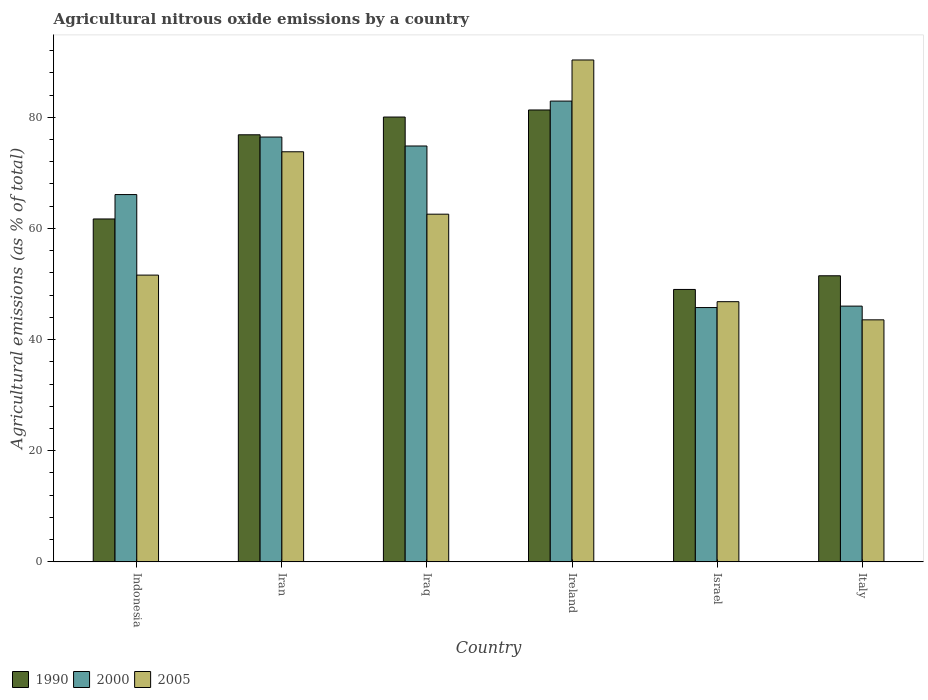How many different coloured bars are there?
Ensure brevity in your answer.  3. Are the number of bars per tick equal to the number of legend labels?
Make the answer very short. Yes. Are the number of bars on each tick of the X-axis equal?
Your answer should be very brief. Yes. How many bars are there on the 3rd tick from the left?
Your answer should be compact. 3. How many bars are there on the 2nd tick from the right?
Your answer should be compact. 3. What is the label of the 3rd group of bars from the left?
Offer a terse response. Iraq. What is the amount of agricultural nitrous oxide emitted in 2000 in Ireland?
Make the answer very short. 82.91. Across all countries, what is the maximum amount of agricultural nitrous oxide emitted in 2000?
Your answer should be very brief. 82.91. Across all countries, what is the minimum amount of agricultural nitrous oxide emitted in 2005?
Give a very brief answer. 43.55. In which country was the amount of agricultural nitrous oxide emitted in 2000 maximum?
Offer a terse response. Ireland. What is the total amount of agricultural nitrous oxide emitted in 2000 in the graph?
Keep it short and to the point. 392.04. What is the difference between the amount of agricultural nitrous oxide emitted in 1990 in Iraq and that in Israel?
Offer a terse response. 31.02. What is the difference between the amount of agricultural nitrous oxide emitted in 1990 in Iraq and the amount of agricultural nitrous oxide emitted in 2000 in Ireland?
Make the answer very short. -2.87. What is the average amount of agricultural nitrous oxide emitted in 1990 per country?
Make the answer very short. 66.73. What is the difference between the amount of agricultural nitrous oxide emitted of/in 1990 and amount of agricultural nitrous oxide emitted of/in 2005 in Iraq?
Provide a succinct answer. 17.48. What is the ratio of the amount of agricultural nitrous oxide emitted in 2000 in Iran to that in Ireland?
Ensure brevity in your answer.  0.92. Is the amount of agricultural nitrous oxide emitted in 2005 in Israel less than that in Italy?
Make the answer very short. No. What is the difference between the highest and the second highest amount of agricultural nitrous oxide emitted in 2005?
Your answer should be very brief. -16.52. What is the difference between the highest and the lowest amount of agricultural nitrous oxide emitted in 1990?
Your response must be concise. 32.29. In how many countries, is the amount of agricultural nitrous oxide emitted in 2005 greater than the average amount of agricultural nitrous oxide emitted in 2005 taken over all countries?
Make the answer very short. 3. Is the sum of the amount of agricultural nitrous oxide emitted in 2005 in Iran and Italy greater than the maximum amount of agricultural nitrous oxide emitted in 1990 across all countries?
Provide a short and direct response. Yes. What does the 3rd bar from the left in Israel represents?
Ensure brevity in your answer.  2005. What does the 2nd bar from the right in Iraq represents?
Make the answer very short. 2000. Is it the case that in every country, the sum of the amount of agricultural nitrous oxide emitted in 2000 and amount of agricultural nitrous oxide emitted in 1990 is greater than the amount of agricultural nitrous oxide emitted in 2005?
Make the answer very short. Yes. What is the difference between two consecutive major ticks on the Y-axis?
Offer a very short reply. 20. Does the graph contain any zero values?
Your answer should be very brief. No. Where does the legend appear in the graph?
Your response must be concise. Bottom left. What is the title of the graph?
Make the answer very short. Agricultural nitrous oxide emissions by a country. What is the label or title of the Y-axis?
Offer a terse response. Agricultural emissions (as % of total). What is the Agricultural emissions (as % of total) of 1990 in Indonesia?
Offer a very short reply. 61.7. What is the Agricultural emissions (as % of total) of 2000 in Indonesia?
Keep it short and to the point. 66.09. What is the Agricultural emissions (as % of total) in 2005 in Indonesia?
Offer a terse response. 51.6. What is the Agricultural emissions (as % of total) in 1990 in Iran?
Provide a succinct answer. 76.84. What is the Agricultural emissions (as % of total) in 2000 in Iran?
Offer a terse response. 76.44. What is the Agricultural emissions (as % of total) of 2005 in Iran?
Provide a short and direct response. 73.79. What is the Agricultural emissions (as % of total) in 1990 in Iraq?
Your response must be concise. 80.04. What is the Agricultural emissions (as % of total) of 2000 in Iraq?
Your response must be concise. 74.83. What is the Agricultural emissions (as % of total) in 2005 in Iraq?
Your answer should be very brief. 62.56. What is the Agricultural emissions (as % of total) in 1990 in Ireland?
Offer a terse response. 81.31. What is the Agricultural emissions (as % of total) in 2000 in Ireland?
Keep it short and to the point. 82.91. What is the Agricultural emissions (as % of total) of 2005 in Ireland?
Keep it short and to the point. 90.31. What is the Agricultural emissions (as % of total) in 1990 in Israel?
Offer a terse response. 49.02. What is the Agricultural emissions (as % of total) of 2000 in Israel?
Provide a succinct answer. 45.76. What is the Agricultural emissions (as % of total) of 2005 in Israel?
Give a very brief answer. 46.82. What is the Agricultural emissions (as % of total) in 1990 in Italy?
Provide a succinct answer. 51.48. What is the Agricultural emissions (as % of total) in 2000 in Italy?
Ensure brevity in your answer.  46.02. What is the Agricultural emissions (as % of total) in 2005 in Italy?
Your answer should be very brief. 43.55. Across all countries, what is the maximum Agricultural emissions (as % of total) in 1990?
Give a very brief answer. 81.31. Across all countries, what is the maximum Agricultural emissions (as % of total) of 2000?
Your answer should be very brief. 82.91. Across all countries, what is the maximum Agricultural emissions (as % of total) in 2005?
Provide a succinct answer. 90.31. Across all countries, what is the minimum Agricultural emissions (as % of total) in 1990?
Give a very brief answer. 49.02. Across all countries, what is the minimum Agricultural emissions (as % of total) in 2000?
Your response must be concise. 45.76. Across all countries, what is the minimum Agricultural emissions (as % of total) of 2005?
Offer a very short reply. 43.55. What is the total Agricultural emissions (as % of total) in 1990 in the graph?
Offer a terse response. 400.39. What is the total Agricultural emissions (as % of total) of 2000 in the graph?
Your answer should be compact. 392.04. What is the total Agricultural emissions (as % of total) in 2005 in the graph?
Ensure brevity in your answer.  368.62. What is the difference between the Agricultural emissions (as % of total) of 1990 in Indonesia and that in Iran?
Provide a succinct answer. -15.14. What is the difference between the Agricultural emissions (as % of total) in 2000 in Indonesia and that in Iran?
Offer a terse response. -10.35. What is the difference between the Agricultural emissions (as % of total) of 2005 in Indonesia and that in Iran?
Give a very brief answer. -22.19. What is the difference between the Agricultural emissions (as % of total) in 1990 in Indonesia and that in Iraq?
Offer a terse response. -18.34. What is the difference between the Agricultural emissions (as % of total) of 2000 in Indonesia and that in Iraq?
Make the answer very short. -8.74. What is the difference between the Agricultural emissions (as % of total) in 2005 in Indonesia and that in Iraq?
Provide a succinct answer. -10.96. What is the difference between the Agricultural emissions (as % of total) of 1990 in Indonesia and that in Ireland?
Offer a terse response. -19.61. What is the difference between the Agricultural emissions (as % of total) in 2000 in Indonesia and that in Ireland?
Provide a short and direct response. -16.82. What is the difference between the Agricultural emissions (as % of total) in 2005 in Indonesia and that in Ireland?
Your answer should be very brief. -38.71. What is the difference between the Agricultural emissions (as % of total) in 1990 in Indonesia and that in Israel?
Provide a short and direct response. 12.68. What is the difference between the Agricultural emissions (as % of total) of 2000 in Indonesia and that in Israel?
Ensure brevity in your answer.  20.33. What is the difference between the Agricultural emissions (as % of total) of 2005 in Indonesia and that in Israel?
Offer a very short reply. 4.78. What is the difference between the Agricultural emissions (as % of total) in 1990 in Indonesia and that in Italy?
Your answer should be very brief. 10.22. What is the difference between the Agricultural emissions (as % of total) in 2000 in Indonesia and that in Italy?
Ensure brevity in your answer.  20.07. What is the difference between the Agricultural emissions (as % of total) of 2005 in Indonesia and that in Italy?
Offer a terse response. 8.05. What is the difference between the Agricultural emissions (as % of total) of 1990 in Iran and that in Iraq?
Provide a succinct answer. -3.19. What is the difference between the Agricultural emissions (as % of total) in 2000 in Iran and that in Iraq?
Provide a short and direct response. 1.61. What is the difference between the Agricultural emissions (as % of total) of 2005 in Iran and that in Iraq?
Your response must be concise. 11.23. What is the difference between the Agricultural emissions (as % of total) in 1990 in Iran and that in Ireland?
Ensure brevity in your answer.  -4.47. What is the difference between the Agricultural emissions (as % of total) of 2000 in Iran and that in Ireland?
Make the answer very short. -6.47. What is the difference between the Agricultural emissions (as % of total) of 2005 in Iran and that in Ireland?
Your answer should be very brief. -16.52. What is the difference between the Agricultural emissions (as % of total) in 1990 in Iran and that in Israel?
Give a very brief answer. 27.83. What is the difference between the Agricultural emissions (as % of total) in 2000 in Iran and that in Israel?
Your answer should be compact. 30.68. What is the difference between the Agricultural emissions (as % of total) in 2005 in Iran and that in Israel?
Give a very brief answer. 26.97. What is the difference between the Agricultural emissions (as % of total) of 1990 in Iran and that in Italy?
Make the answer very short. 25.37. What is the difference between the Agricultural emissions (as % of total) in 2000 in Iran and that in Italy?
Ensure brevity in your answer.  30.42. What is the difference between the Agricultural emissions (as % of total) of 2005 in Iran and that in Italy?
Provide a succinct answer. 30.24. What is the difference between the Agricultural emissions (as % of total) in 1990 in Iraq and that in Ireland?
Ensure brevity in your answer.  -1.27. What is the difference between the Agricultural emissions (as % of total) of 2000 in Iraq and that in Ireland?
Give a very brief answer. -8.08. What is the difference between the Agricultural emissions (as % of total) of 2005 in Iraq and that in Ireland?
Give a very brief answer. -27.75. What is the difference between the Agricultural emissions (as % of total) of 1990 in Iraq and that in Israel?
Your answer should be compact. 31.02. What is the difference between the Agricultural emissions (as % of total) in 2000 in Iraq and that in Israel?
Ensure brevity in your answer.  29.07. What is the difference between the Agricultural emissions (as % of total) in 2005 in Iraq and that in Israel?
Give a very brief answer. 15.74. What is the difference between the Agricultural emissions (as % of total) in 1990 in Iraq and that in Italy?
Offer a terse response. 28.56. What is the difference between the Agricultural emissions (as % of total) in 2000 in Iraq and that in Italy?
Make the answer very short. 28.81. What is the difference between the Agricultural emissions (as % of total) of 2005 in Iraq and that in Italy?
Your response must be concise. 19.01. What is the difference between the Agricultural emissions (as % of total) in 1990 in Ireland and that in Israel?
Give a very brief answer. 32.29. What is the difference between the Agricultural emissions (as % of total) of 2000 in Ireland and that in Israel?
Provide a short and direct response. 37.15. What is the difference between the Agricultural emissions (as % of total) of 2005 in Ireland and that in Israel?
Give a very brief answer. 43.49. What is the difference between the Agricultural emissions (as % of total) in 1990 in Ireland and that in Italy?
Ensure brevity in your answer.  29.83. What is the difference between the Agricultural emissions (as % of total) in 2000 in Ireland and that in Italy?
Provide a short and direct response. 36.89. What is the difference between the Agricultural emissions (as % of total) of 2005 in Ireland and that in Italy?
Your answer should be compact. 46.76. What is the difference between the Agricultural emissions (as % of total) in 1990 in Israel and that in Italy?
Ensure brevity in your answer.  -2.46. What is the difference between the Agricultural emissions (as % of total) of 2000 in Israel and that in Italy?
Offer a very short reply. -0.26. What is the difference between the Agricultural emissions (as % of total) of 2005 in Israel and that in Italy?
Provide a succinct answer. 3.27. What is the difference between the Agricultural emissions (as % of total) of 1990 in Indonesia and the Agricultural emissions (as % of total) of 2000 in Iran?
Your response must be concise. -14.74. What is the difference between the Agricultural emissions (as % of total) of 1990 in Indonesia and the Agricultural emissions (as % of total) of 2005 in Iran?
Offer a very short reply. -12.09. What is the difference between the Agricultural emissions (as % of total) of 2000 in Indonesia and the Agricultural emissions (as % of total) of 2005 in Iran?
Your response must be concise. -7.7. What is the difference between the Agricultural emissions (as % of total) of 1990 in Indonesia and the Agricultural emissions (as % of total) of 2000 in Iraq?
Give a very brief answer. -13.13. What is the difference between the Agricultural emissions (as % of total) of 1990 in Indonesia and the Agricultural emissions (as % of total) of 2005 in Iraq?
Keep it short and to the point. -0.86. What is the difference between the Agricultural emissions (as % of total) in 2000 in Indonesia and the Agricultural emissions (as % of total) in 2005 in Iraq?
Your answer should be very brief. 3.53. What is the difference between the Agricultural emissions (as % of total) of 1990 in Indonesia and the Agricultural emissions (as % of total) of 2000 in Ireland?
Your answer should be compact. -21.21. What is the difference between the Agricultural emissions (as % of total) of 1990 in Indonesia and the Agricultural emissions (as % of total) of 2005 in Ireland?
Ensure brevity in your answer.  -28.61. What is the difference between the Agricultural emissions (as % of total) in 2000 in Indonesia and the Agricultural emissions (as % of total) in 2005 in Ireland?
Your answer should be very brief. -24.22. What is the difference between the Agricultural emissions (as % of total) of 1990 in Indonesia and the Agricultural emissions (as % of total) of 2000 in Israel?
Give a very brief answer. 15.94. What is the difference between the Agricultural emissions (as % of total) of 1990 in Indonesia and the Agricultural emissions (as % of total) of 2005 in Israel?
Give a very brief answer. 14.88. What is the difference between the Agricultural emissions (as % of total) of 2000 in Indonesia and the Agricultural emissions (as % of total) of 2005 in Israel?
Provide a succinct answer. 19.27. What is the difference between the Agricultural emissions (as % of total) in 1990 in Indonesia and the Agricultural emissions (as % of total) in 2000 in Italy?
Your answer should be very brief. 15.68. What is the difference between the Agricultural emissions (as % of total) in 1990 in Indonesia and the Agricultural emissions (as % of total) in 2005 in Italy?
Provide a short and direct response. 18.15. What is the difference between the Agricultural emissions (as % of total) in 2000 in Indonesia and the Agricultural emissions (as % of total) in 2005 in Italy?
Your answer should be compact. 22.54. What is the difference between the Agricultural emissions (as % of total) of 1990 in Iran and the Agricultural emissions (as % of total) of 2000 in Iraq?
Ensure brevity in your answer.  2.02. What is the difference between the Agricultural emissions (as % of total) in 1990 in Iran and the Agricultural emissions (as % of total) in 2005 in Iraq?
Ensure brevity in your answer.  14.29. What is the difference between the Agricultural emissions (as % of total) of 2000 in Iran and the Agricultural emissions (as % of total) of 2005 in Iraq?
Your answer should be compact. 13.88. What is the difference between the Agricultural emissions (as % of total) in 1990 in Iran and the Agricultural emissions (as % of total) in 2000 in Ireland?
Offer a very short reply. -6.06. What is the difference between the Agricultural emissions (as % of total) in 1990 in Iran and the Agricultural emissions (as % of total) in 2005 in Ireland?
Keep it short and to the point. -13.46. What is the difference between the Agricultural emissions (as % of total) in 2000 in Iran and the Agricultural emissions (as % of total) in 2005 in Ireland?
Make the answer very short. -13.87. What is the difference between the Agricultural emissions (as % of total) of 1990 in Iran and the Agricultural emissions (as % of total) of 2000 in Israel?
Provide a succinct answer. 31.08. What is the difference between the Agricultural emissions (as % of total) of 1990 in Iran and the Agricultural emissions (as % of total) of 2005 in Israel?
Provide a short and direct response. 30.03. What is the difference between the Agricultural emissions (as % of total) in 2000 in Iran and the Agricultural emissions (as % of total) in 2005 in Israel?
Ensure brevity in your answer.  29.62. What is the difference between the Agricultural emissions (as % of total) in 1990 in Iran and the Agricultural emissions (as % of total) in 2000 in Italy?
Make the answer very short. 30.83. What is the difference between the Agricultural emissions (as % of total) of 1990 in Iran and the Agricultural emissions (as % of total) of 2005 in Italy?
Your answer should be compact. 33.3. What is the difference between the Agricultural emissions (as % of total) of 2000 in Iran and the Agricultural emissions (as % of total) of 2005 in Italy?
Your answer should be very brief. 32.89. What is the difference between the Agricultural emissions (as % of total) in 1990 in Iraq and the Agricultural emissions (as % of total) in 2000 in Ireland?
Offer a very short reply. -2.87. What is the difference between the Agricultural emissions (as % of total) in 1990 in Iraq and the Agricultural emissions (as % of total) in 2005 in Ireland?
Your answer should be compact. -10.27. What is the difference between the Agricultural emissions (as % of total) of 2000 in Iraq and the Agricultural emissions (as % of total) of 2005 in Ireland?
Make the answer very short. -15.48. What is the difference between the Agricultural emissions (as % of total) of 1990 in Iraq and the Agricultural emissions (as % of total) of 2000 in Israel?
Offer a very short reply. 34.28. What is the difference between the Agricultural emissions (as % of total) of 1990 in Iraq and the Agricultural emissions (as % of total) of 2005 in Israel?
Your response must be concise. 33.22. What is the difference between the Agricultural emissions (as % of total) of 2000 in Iraq and the Agricultural emissions (as % of total) of 2005 in Israel?
Offer a terse response. 28.01. What is the difference between the Agricultural emissions (as % of total) in 1990 in Iraq and the Agricultural emissions (as % of total) in 2000 in Italy?
Your answer should be very brief. 34.02. What is the difference between the Agricultural emissions (as % of total) in 1990 in Iraq and the Agricultural emissions (as % of total) in 2005 in Italy?
Your answer should be compact. 36.49. What is the difference between the Agricultural emissions (as % of total) of 2000 in Iraq and the Agricultural emissions (as % of total) of 2005 in Italy?
Provide a short and direct response. 31.28. What is the difference between the Agricultural emissions (as % of total) of 1990 in Ireland and the Agricultural emissions (as % of total) of 2000 in Israel?
Provide a succinct answer. 35.55. What is the difference between the Agricultural emissions (as % of total) of 1990 in Ireland and the Agricultural emissions (as % of total) of 2005 in Israel?
Your answer should be compact. 34.49. What is the difference between the Agricultural emissions (as % of total) of 2000 in Ireland and the Agricultural emissions (as % of total) of 2005 in Israel?
Your response must be concise. 36.09. What is the difference between the Agricultural emissions (as % of total) in 1990 in Ireland and the Agricultural emissions (as % of total) in 2000 in Italy?
Make the answer very short. 35.29. What is the difference between the Agricultural emissions (as % of total) of 1990 in Ireland and the Agricultural emissions (as % of total) of 2005 in Italy?
Offer a very short reply. 37.76. What is the difference between the Agricultural emissions (as % of total) in 2000 in Ireland and the Agricultural emissions (as % of total) in 2005 in Italy?
Your response must be concise. 39.36. What is the difference between the Agricultural emissions (as % of total) of 1990 in Israel and the Agricultural emissions (as % of total) of 2000 in Italy?
Provide a short and direct response. 3. What is the difference between the Agricultural emissions (as % of total) of 1990 in Israel and the Agricultural emissions (as % of total) of 2005 in Italy?
Your response must be concise. 5.47. What is the difference between the Agricultural emissions (as % of total) of 2000 in Israel and the Agricultural emissions (as % of total) of 2005 in Italy?
Keep it short and to the point. 2.21. What is the average Agricultural emissions (as % of total) in 1990 per country?
Keep it short and to the point. 66.73. What is the average Agricultural emissions (as % of total) in 2000 per country?
Offer a very short reply. 65.34. What is the average Agricultural emissions (as % of total) in 2005 per country?
Give a very brief answer. 61.44. What is the difference between the Agricultural emissions (as % of total) of 1990 and Agricultural emissions (as % of total) of 2000 in Indonesia?
Your answer should be compact. -4.39. What is the difference between the Agricultural emissions (as % of total) of 1990 and Agricultural emissions (as % of total) of 2005 in Indonesia?
Offer a very short reply. 10.1. What is the difference between the Agricultural emissions (as % of total) of 2000 and Agricultural emissions (as % of total) of 2005 in Indonesia?
Offer a terse response. 14.49. What is the difference between the Agricultural emissions (as % of total) in 1990 and Agricultural emissions (as % of total) in 2000 in Iran?
Offer a very short reply. 0.4. What is the difference between the Agricultural emissions (as % of total) of 1990 and Agricultural emissions (as % of total) of 2005 in Iran?
Offer a very short reply. 3.06. What is the difference between the Agricultural emissions (as % of total) of 2000 and Agricultural emissions (as % of total) of 2005 in Iran?
Your response must be concise. 2.65. What is the difference between the Agricultural emissions (as % of total) of 1990 and Agricultural emissions (as % of total) of 2000 in Iraq?
Make the answer very short. 5.21. What is the difference between the Agricultural emissions (as % of total) in 1990 and Agricultural emissions (as % of total) in 2005 in Iraq?
Provide a succinct answer. 17.48. What is the difference between the Agricultural emissions (as % of total) of 2000 and Agricultural emissions (as % of total) of 2005 in Iraq?
Give a very brief answer. 12.27. What is the difference between the Agricultural emissions (as % of total) in 1990 and Agricultural emissions (as % of total) in 2000 in Ireland?
Make the answer very short. -1.6. What is the difference between the Agricultural emissions (as % of total) in 1990 and Agricultural emissions (as % of total) in 2005 in Ireland?
Your answer should be compact. -9. What is the difference between the Agricultural emissions (as % of total) in 2000 and Agricultural emissions (as % of total) in 2005 in Ireland?
Your answer should be compact. -7.4. What is the difference between the Agricultural emissions (as % of total) of 1990 and Agricultural emissions (as % of total) of 2000 in Israel?
Ensure brevity in your answer.  3.26. What is the difference between the Agricultural emissions (as % of total) in 1990 and Agricultural emissions (as % of total) in 2005 in Israel?
Your answer should be compact. 2.2. What is the difference between the Agricultural emissions (as % of total) of 2000 and Agricultural emissions (as % of total) of 2005 in Israel?
Your response must be concise. -1.06. What is the difference between the Agricultural emissions (as % of total) of 1990 and Agricultural emissions (as % of total) of 2000 in Italy?
Your answer should be compact. 5.46. What is the difference between the Agricultural emissions (as % of total) in 1990 and Agricultural emissions (as % of total) in 2005 in Italy?
Keep it short and to the point. 7.93. What is the difference between the Agricultural emissions (as % of total) of 2000 and Agricultural emissions (as % of total) of 2005 in Italy?
Your response must be concise. 2.47. What is the ratio of the Agricultural emissions (as % of total) of 1990 in Indonesia to that in Iran?
Provide a succinct answer. 0.8. What is the ratio of the Agricultural emissions (as % of total) in 2000 in Indonesia to that in Iran?
Provide a succinct answer. 0.86. What is the ratio of the Agricultural emissions (as % of total) of 2005 in Indonesia to that in Iran?
Provide a succinct answer. 0.7. What is the ratio of the Agricultural emissions (as % of total) in 1990 in Indonesia to that in Iraq?
Your answer should be compact. 0.77. What is the ratio of the Agricultural emissions (as % of total) of 2000 in Indonesia to that in Iraq?
Your answer should be compact. 0.88. What is the ratio of the Agricultural emissions (as % of total) in 2005 in Indonesia to that in Iraq?
Provide a short and direct response. 0.82. What is the ratio of the Agricultural emissions (as % of total) in 1990 in Indonesia to that in Ireland?
Ensure brevity in your answer.  0.76. What is the ratio of the Agricultural emissions (as % of total) of 2000 in Indonesia to that in Ireland?
Give a very brief answer. 0.8. What is the ratio of the Agricultural emissions (as % of total) of 2005 in Indonesia to that in Ireland?
Provide a short and direct response. 0.57. What is the ratio of the Agricultural emissions (as % of total) in 1990 in Indonesia to that in Israel?
Your response must be concise. 1.26. What is the ratio of the Agricultural emissions (as % of total) in 2000 in Indonesia to that in Israel?
Your answer should be very brief. 1.44. What is the ratio of the Agricultural emissions (as % of total) in 2005 in Indonesia to that in Israel?
Your answer should be very brief. 1.1. What is the ratio of the Agricultural emissions (as % of total) in 1990 in Indonesia to that in Italy?
Offer a very short reply. 1.2. What is the ratio of the Agricultural emissions (as % of total) of 2000 in Indonesia to that in Italy?
Make the answer very short. 1.44. What is the ratio of the Agricultural emissions (as % of total) in 2005 in Indonesia to that in Italy?
Provide a short and direct response. 1.18. What is the ratio of the Agricultural emissions (as % of total) of 1990 in Iran to that in Iraq?
Your answer should be very brief. 0.96. What is the ratio of the Agricultural emissions (as % of total) of 2000 in Iran to that in Iraq?
Your response must be concise. 1.02. What is the ratio of the Agricultural emissions (as % of total) of 2005 in Iran to that in Iraq?
Your answer should be compact. 1.18. What is the ratio of the Agricultural emissions (as % of total) of 1990 in Iran to that in Ireland?
Ensure brevity in your answer.  0.95. What is the ratio of the Agricultural emissions (as % of total) of 2000 in Iran to that in Ireland?
Your answer should be very brief. 0.92. What is the ratio of the Agricultural emissions (as % of total) in 2005 in Iran to that in Ireland?
Provide a succinct answer. 0.82. What is the ratio of the Agricultural emissions (as % of total) of 1990 in Iran to that in Israel?
Provide a succinct answer. 1.57. What is the ratio of the Agricultural emissions (as % of total) of 2000 in Iran to that in Israel?
Keep it short and to the point. 1.67. What is the ratio of the Agricultural emissions (as % of total) in 2005 in Iran to that in Israel?
Keep it short and to the point. 1.58. What is the ratio of the Agricultural emissions (as % of total) in 1990 in Iran to that in Italy?
Offer a terse response. 1.49. What is the ratio of the Agricultural emissions (as % of total) of 2000 in Iran to that in Italy?
Provide a succinct answer. 1.66. What is the ratio of the Agricultural emissions (as % of total) in 2005 in Iran to that in Italy?
Offer a terse response. 1.69. What is the ratio of the Agricultural emissions (as % of total) of 1990 in Iraq to that in Ireland?
Make the answer very short. 0.98. What is the ratio of the Agricultural emissions (as % of total) of 2000 in Iraq to that in Ireland?
Your response must be concise. 0.9. What is the ratio of the Agricultural emissions (as % of total) in 2005 in Iraq to that in Ireland?
Keep it short and to the point. 0.69. What is the ratio of the Agricultural emissions (as % of total) of 1990 in Iraq to that in Israel?
Make the answer very short. 1.63. What is the ratio of the Agricultural emissions (as % of total) of 2000 in Iraq to that in Israel?
Your answer should be compact. 1.64. What is the ratio of the Agricultural emissions (as % of total) of 2005 in Iraq to that in Israel?
Ensure brevity in your answer.  1.34. What is the ratio of the Agricultural emissions (as % of total) of 1990 in Iraq to that in Italy?
Ensure brevity in your answer.  1.55. What is the ratio of the Agricultural emissions (as % of total) in 2000 in Iraq to that in Italy?
Your answer should be compact. 1.63. What is the ratio of the Agricultural emissions (as % of total) in 2005 in Iraq to that in Italy?
Provide a short and direct response. 1.44. What is the ratio of the Agricultural emissions (as % of total) of 1990 in Ireland to that in Israel?
Offer a very short reply. 1.66. What is the ratio of the Agricultural emissions (as % of total) in 2000 in Ireland to that in Israel?
Provide a succinct answer. 1.81. What is the ratio of the Agricultural emissions (as % of total) in 2005 in Ireland to that in Israel?
Offer a terse response. 1.93. What is the ratio of the Agricultural emissions (as % of total) of 1990 in Ireland to that in Italy?
Provide a short and direct response. 1.58. What is the ratio of the Agricultural emissions (as % of total) in 2000 in Ireland to that in Italy?
Provide a short and direct response. 1.8. What is the ratio of the Agricultural emissions (as % of total) in 2005 in Ireland to that in Italy?
Your response must be concise. 2.07. What is the ratio of the Agricultural emissions (as % of total) in 1990 in Israel to that in Italy?
Ensure brevity in your answer.  0.95. What is the ratio of the Agricultural emissions (as % of total) of 2000 in Israel to that in Italy?
Offer a terse response. 0.99. What is the ratio of the Agricultural emissions (as % of total) in 2005 in Israel to that in Italy?
Provide a short and direct response. 1.07. What is the difference between the highest and the second highest Agricultural emissions (as % of total) in 1990?
Your answer should be very brief. 1.27. What is the difference between the highest and the second highest Agricultural emissions (as % of total) of 2000?
Make the answer very short. 6.47. What is the difference between the highest and the second highest Agricultural emissions (as % of total) in 2005?
Keep it short and to the point. 16.52. What is the difference between the highest and the lowest Agricultural emissions (as % of total) of 1990?
Offer a very short reply. 32.29. What is the difference between the highest and the lowest Agricultural emissions (as % of total) of 2000?
Offer a very short reply. 37.15. What is the difference between the highest and the lowest Agricultural emissions (as % of total) in 2005?
Offer a terse response. 46.76. 